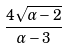Convert formula to latex. <formula><loc_0><loc_0><loc_500><loc_500>\frac { 4 \sqrt { \alpha - 2 } } { \alpha - 3 }</formula> 